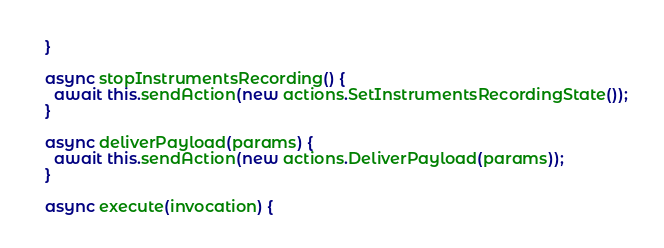Convert code to text. <code><loc_0><loc_0><loc_500><loc_500><_JavaScript_>  }

  async stopInstrumentsRecording() {
    await this.sendAction(new actions.SetInstrumentsRecordingState());
  }

  async deliverPayload(params) {
    await this.sendAction(new actions.DeliverPayload(params));
  }

  async execute(invocation) {</code> 